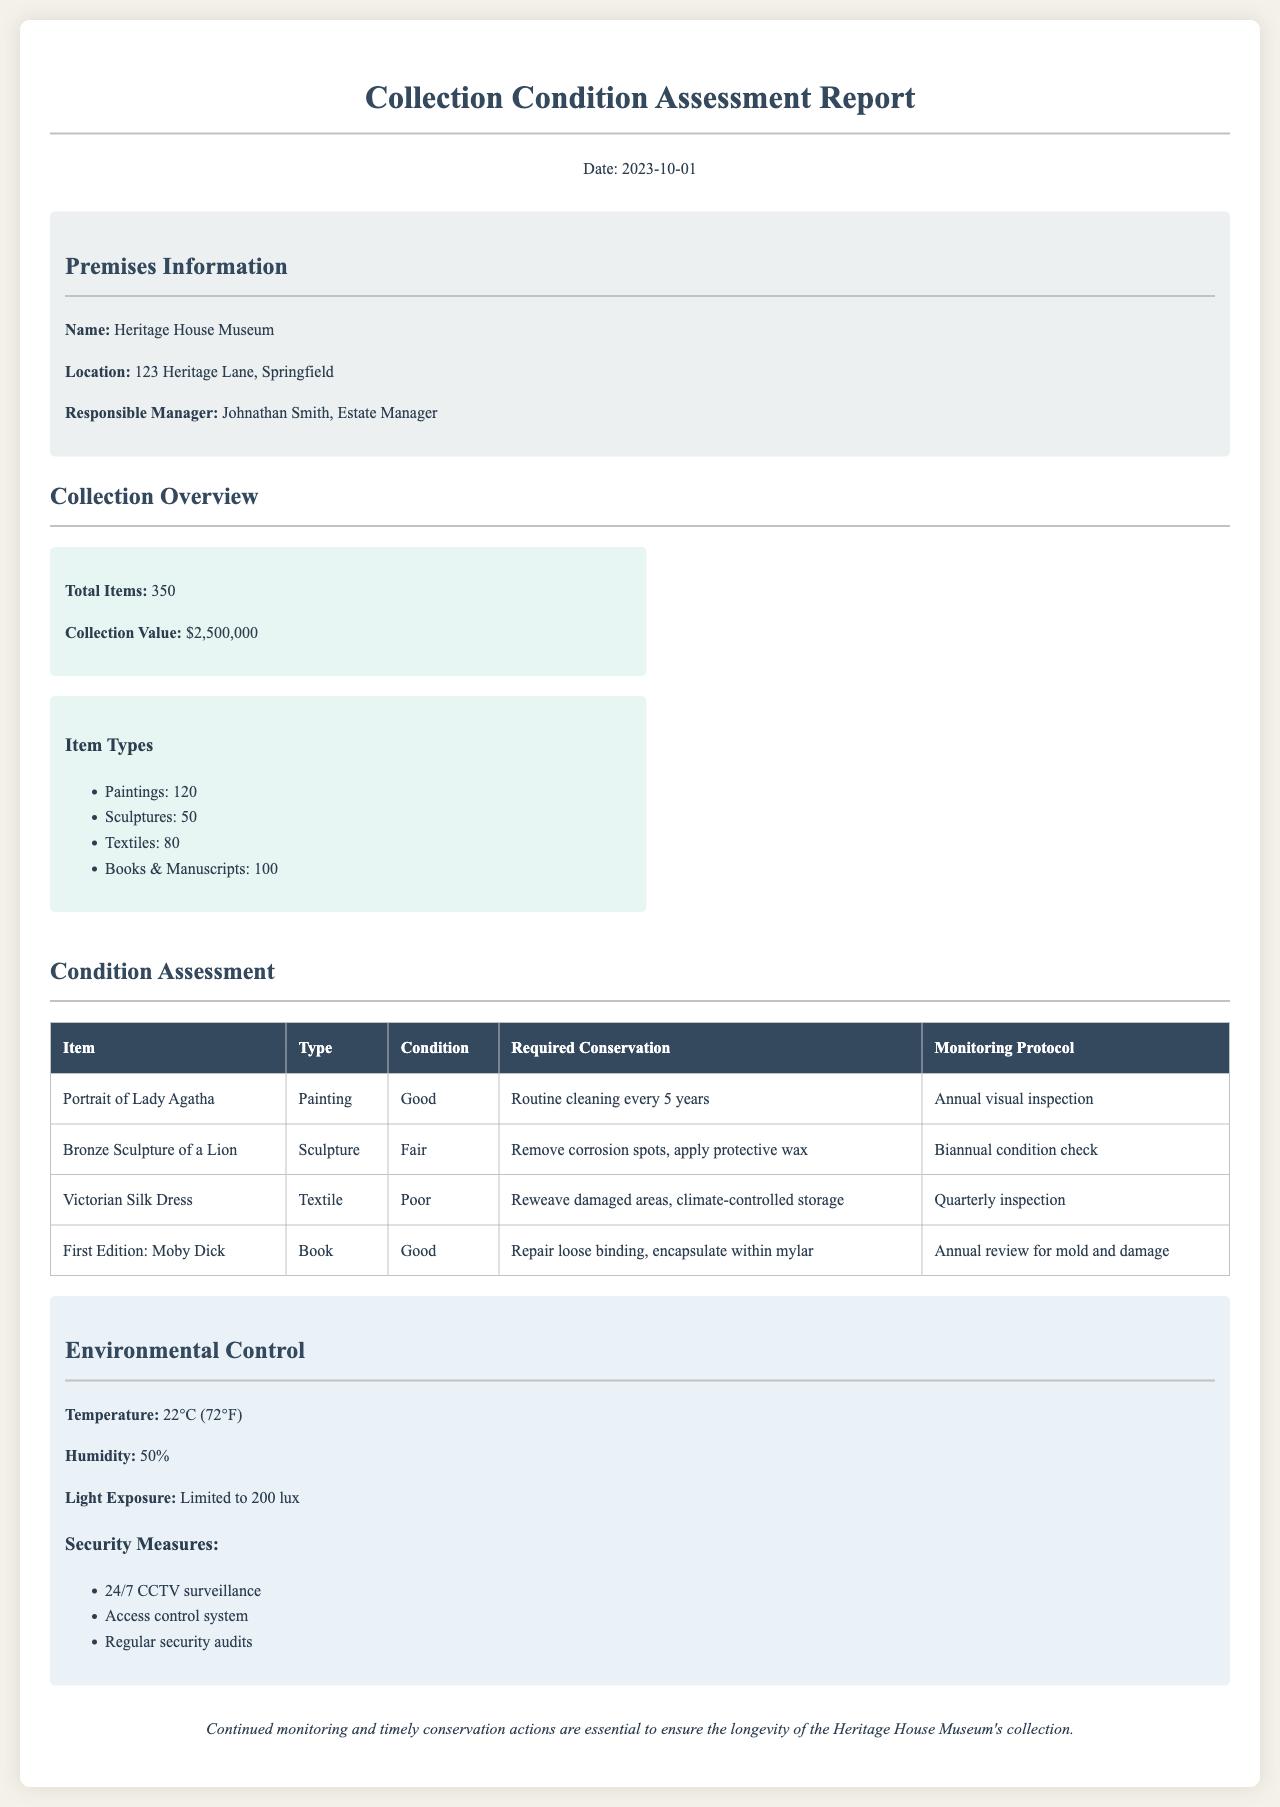what is the total number of items in the collection? The total number of items is stated to be 350 in the Collection Overview section.
Answer: 350 who is the responsible manager for the Heritage House Museum? The responsible manager is mentioned in the Premises Information section.
Answer: Johnathan Smith what is the condition of the Bronze Sculpture of a Lion? The condition of the Bronze Sculpture of a Lion is evaluated in the Condition Assessment table.
Answer: Fair what conservation measure is required for the Victorian Silk Dress? The required conservation measures for the Victorian Silk Dress are outlined in the Condition Assessment section.
Answer: Reweave damaged areas, climate-controlled storage what is the current temperature in the museum? The current temperature is provided in the Environmental Control section.
Answer: 22°C (72°F) how often should the Portrait of Lady Agatha be visually inspected? The frequency of visual inspections is specified in the Condition Assessment table.
Answer: Annual what type of security measure includes access restrictions? The type of security measures related to access restrictions is outlined in the Environmental Control section.
Answer: Access control system how often should the Bronze Sculpture of a Lion undergo condition checks? The frequency of condition checks for the Bronze Sculpture of a Lion is specified in the Condition Assessment table.
Answer: Biannual what is the maximum allowed light exposure for the collection? The maximum light exposure allowed is provided in the Environmental Control section.
Answer: 200 lux 